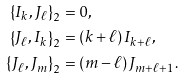Convert formula to latex. <formula><loc_0><loc_0><loc_500><loc_500>\left \{ I _ { k } , J _ { \ell } \right \} _ { 2 } & = 0 , \\ \left \{ J _ { \ell } , I _ { k } \right \} _ { 2 } & = \left ( k + \ell \right ) I _ { k + \ell } , \\ \left \{ J _ { \ell } , J _ { m } \right \} _ { 2 } & = \left ( m - \ell \right ) J _ { m + \ell + 1 } .</formula> 